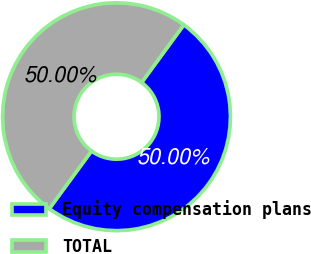Convert chart to OTSL. <chart><loc_0><loc_0><loc_500><loc_500><pie_chart><fcel>Equity compensation plans<fcel>TOTAL<nl><fcel>50.0%<fcel>50.0%<nl></chart> 